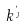<formula> <loc_0><loc_0><loc_500><loc_500>k ^ { \theta _ { \eta } }</formula> 